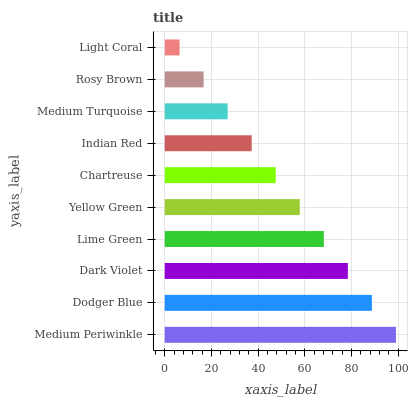Is Light Coral the minimum?
Answer yes or no. Yes. Is Medium Periwinkle the maximum?
Answer yes or no. Yes. Is Dodger Blue the minimum?
Answer yes or no. No. Is Dodger Blue the maximum?
Answer yes or no. No. Is Medium Periwinkle greater than Dodger Blue?
Answer yes or no. Yes. Is Dodger Blue less than Medium Periwinkle?
Answer yes or no. Yes. Is Dodger Blue greater than Medium Periwinkle?
Answer yes or no. No. Is Medium Periwinkle less than Dodger Blue?
Answer yes or no. No. Is Yellow Green the high median?
Answer yes or no. Yes. Is Chartreuse the low median?
Answer yes or no. Yes. Is Rosy Brown the high median?
Answer yes or no. No. Is Yellow Green the low median?
Answer yes or no. No. 